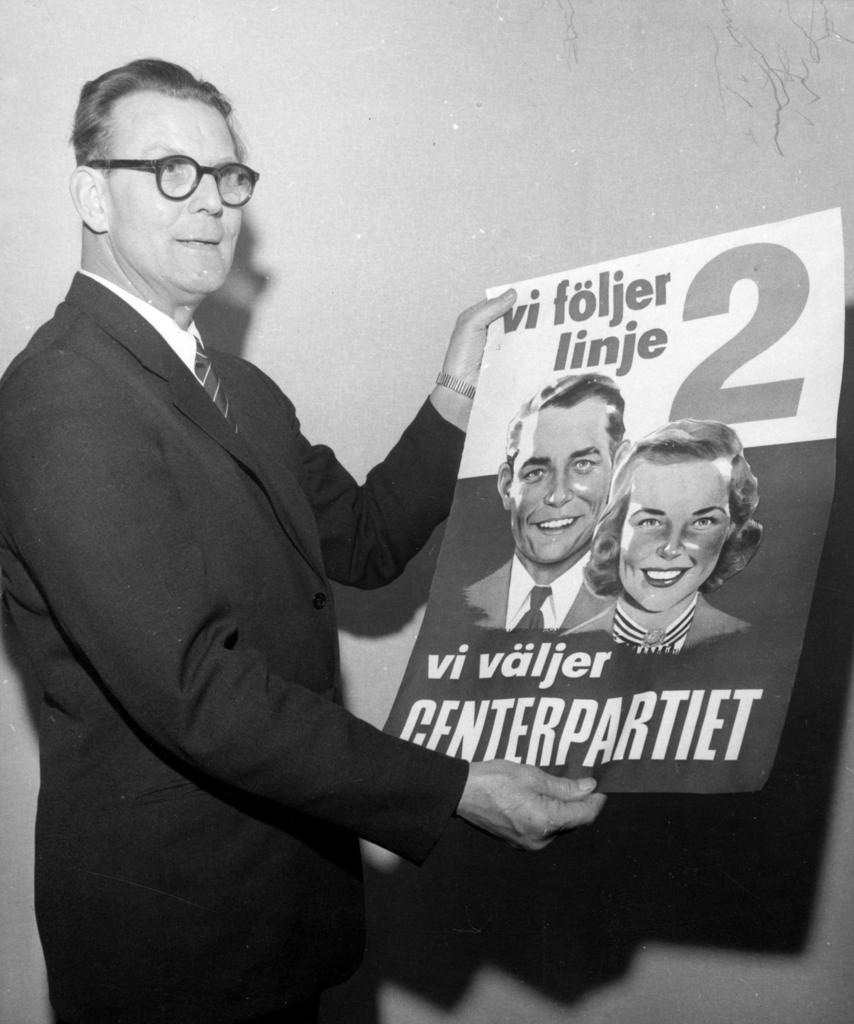What is the color scheme of the photograph? The photograph is black and white. Who is in the photograph? There is a man in the photograph. What is the man doing in the photograph? The man is standing near a wall. What is the man holding in the photograph? The man is holding a magazine. What is the man wearing in the photograph? The man is wearing a black color blazer, a tie, and a shirt. Are there any feathers visible in the photograph? No, there are no feathers visible in the photograph. Is the man in the photograph a beggar? There is no indication in the photograph that the man is a beggar. Is the photograph taken at a zoo? There is no information in the photograph or the provided facts to suggest that it was taken at a zoo. 